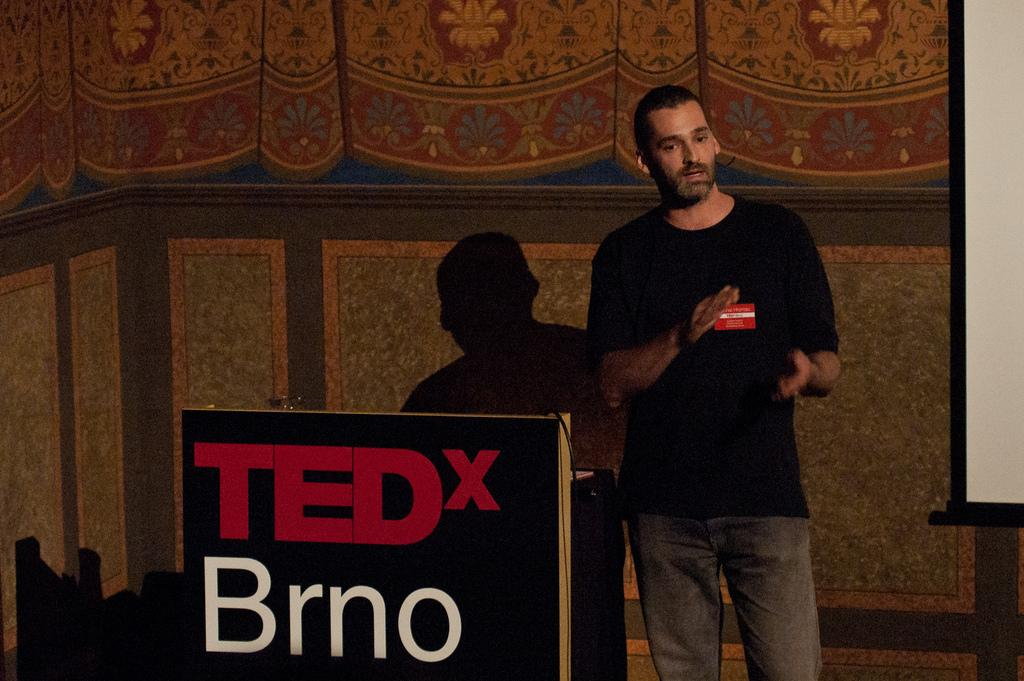What is the main subject of the image? There is a man standing in the image. What is the man wearing? The man is wearing clothes. What is the man doing in the image? The man is talking. What object is present in the image that the man might be using for support or display? There is a podium in the image. What can be seen on the podium? There is text on the podium. What other object is present in the image that might be used for displaying information? There is a whiteboard in the image. What can be seen in the background of the image? There is a wall visible in the image. Can you tell me how many cups are on the whiteboard in the image? There are no cups present on the whiteboard in the image. What type of finger is shown pointing at the text on the podium? There are no fingers visible in the image; only the man's hands are present, and they are not pointing at the text. 